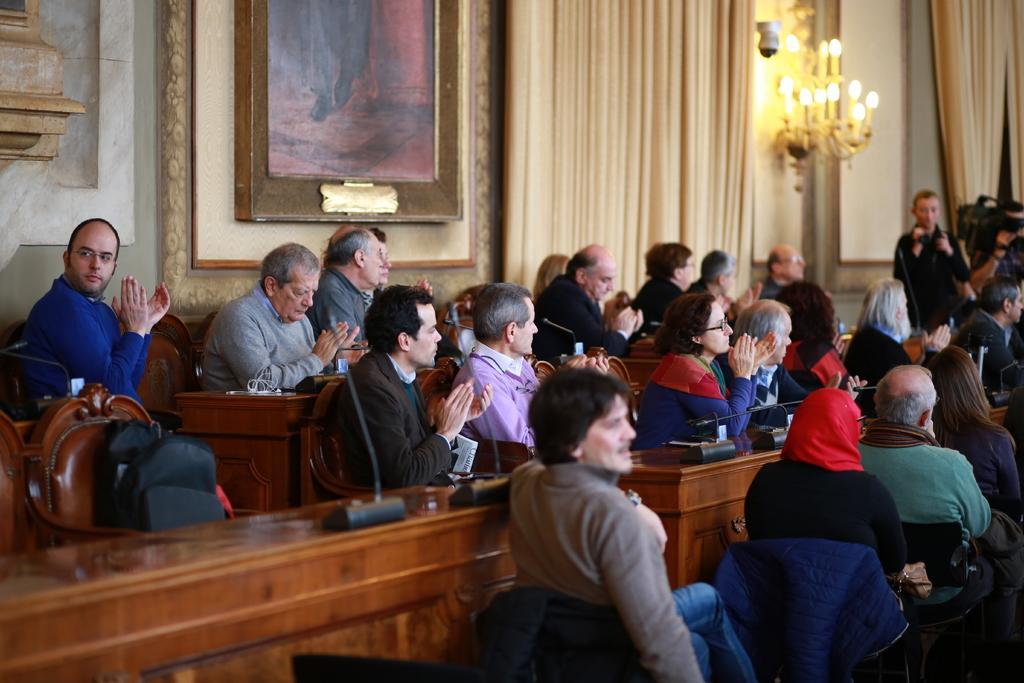Can you describe this image briefly? This picture is taken inside the room. In this image, we can see a group of people sitting on the chair in front of the table, on the table, we can see a microphone and some electrical wires. On the left side, we can also see a bag. in the background, we can see a photo frame which is attached to a wall, curtains and few lights. In the background, we can also see a camera. 